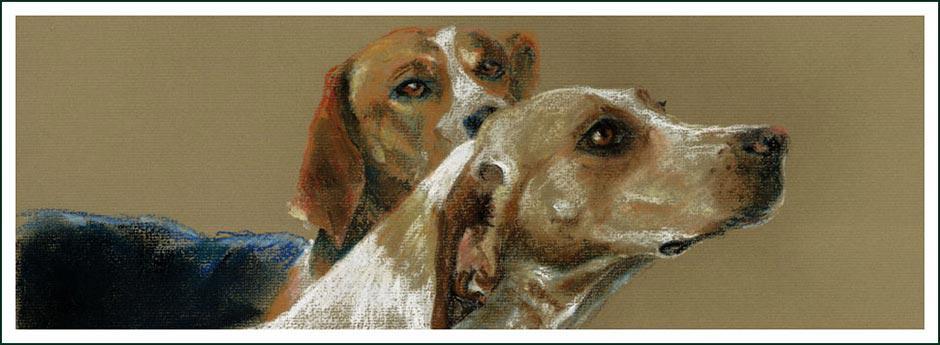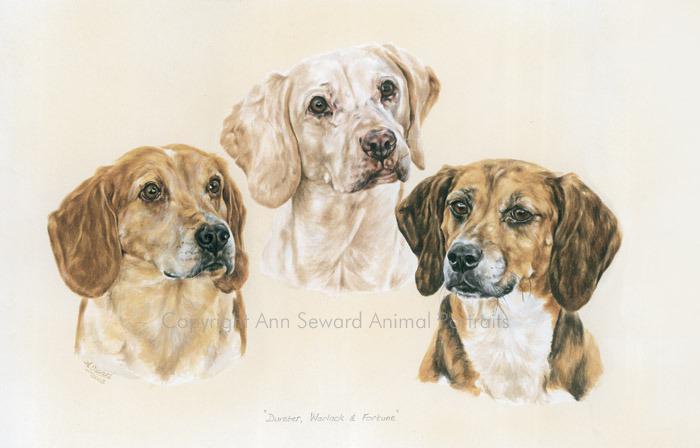The first image is the image on the left, the second image is the image on the right. Analyze the images presented: Is the assertion "One image shows multiple dogs moving forward, and the other image shows a single camera-facing hound." valid? Answer yes or no. No. 